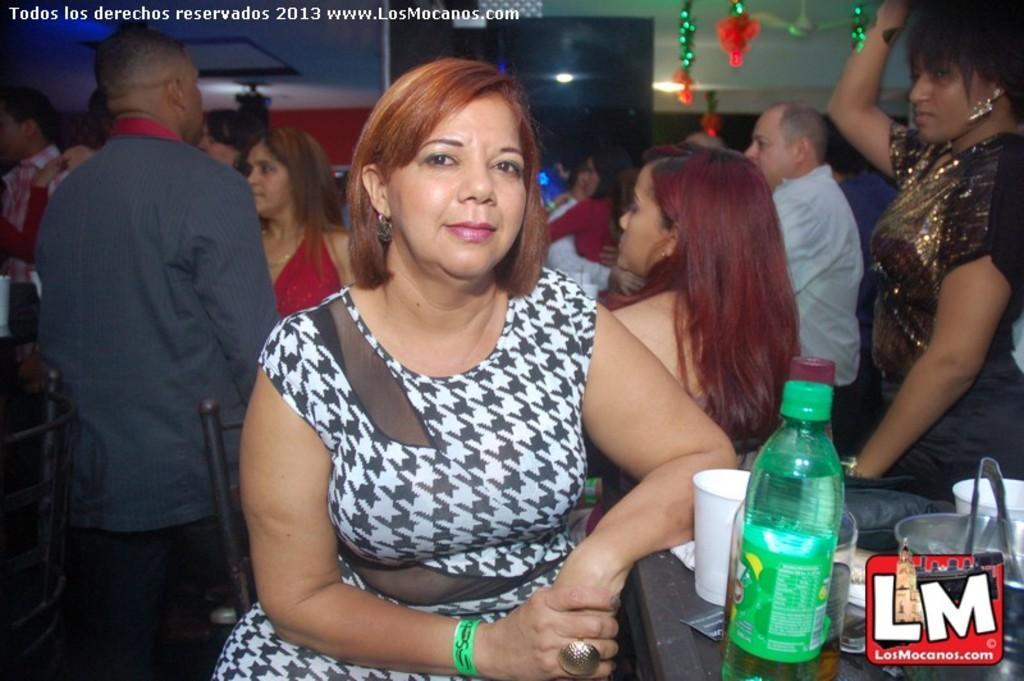Could you give a brief overview of what you see in this image? This picture is of inside. On the right there is a woman standing and a table on the top of which bottle, glasses and some other items are placed. In the center there is a woman wearing white color dress and sitting on the chair. In the background we can see the group of people seems to be standing and there is a ceiling fan, lights and wall in the background and there is a watermark on the image. 